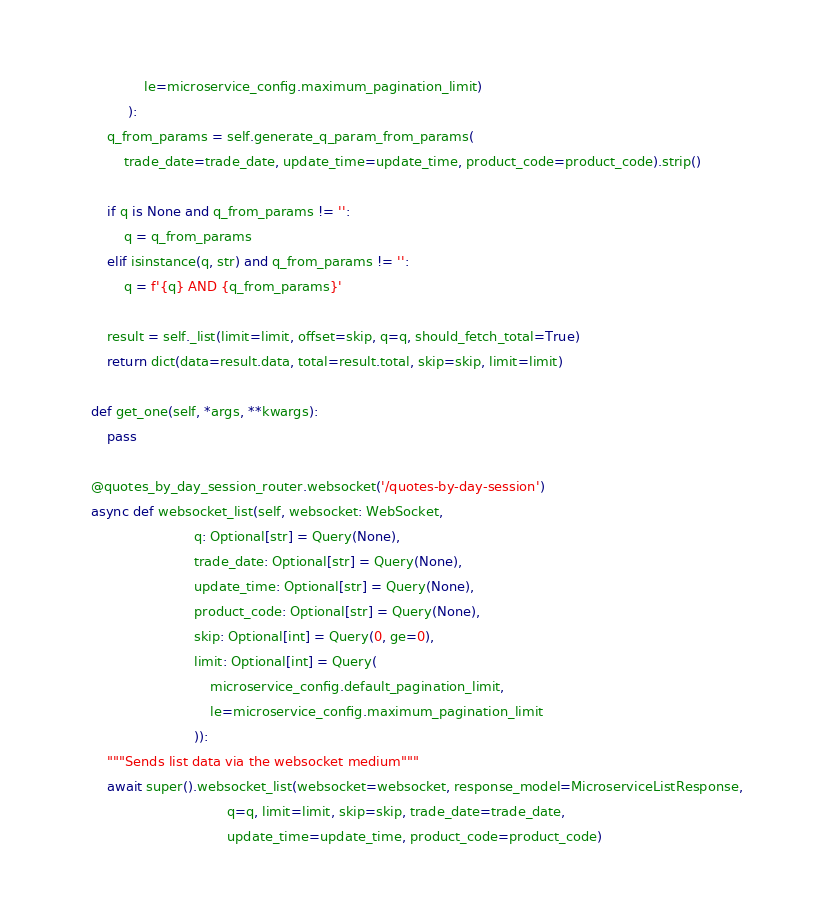Convert code to text. <code><loc_0><loc_0><loc_500><loc_500><_Python_>                 le=microservice_config.maximum_pagination_limit)
             ):
        q_from_params = self.generate_q_param_from_params(
            trade_date=trade_date, update_time=update_time, product_code=product_code).strip()

        if q is None and q_from_params != '':
            q = q_from_params
        elif isinstance(q, str) and q_from_params != '':
            q = f'{q} AND {q_from_params}'

        result = self._list(limit=limit, offset=skip, q=q, should_fetch_total=True)
        return dict(data=result.data, total=result.total, skip=skip, limit=limit)

    def get_one(self, *args, **kwargs):
        pass

    @quotes_by_day_session_router.websocket('/quotes-by-day-session')
    async def websocket_list(self, websocket: WebSocket,
                             q: Optional[str] = Query(None),
                             trade_date: Optional[str] = Query(None),
                             update_time: Optional[str] = Query(None),
                             product_code: Optional[str] = Query(None),
                             skip: Optional[int] = Query(0, ge=0),
                             limit: Optional[int] = Query(
                                 microservice_config.default_pagination_limit,
                                 le=microservice_config.maximum_pagination_limit
                             )):
        """Sends list data via the websocket medium"""
        await super().websocket_list(websocket=websocket, response_model=MicroserviceListResponse,
                                     q=q, limit=limit, skip=skip, trade_date=trade_date,
                                     update_time=update_time, product_code=product_code)
</code> 